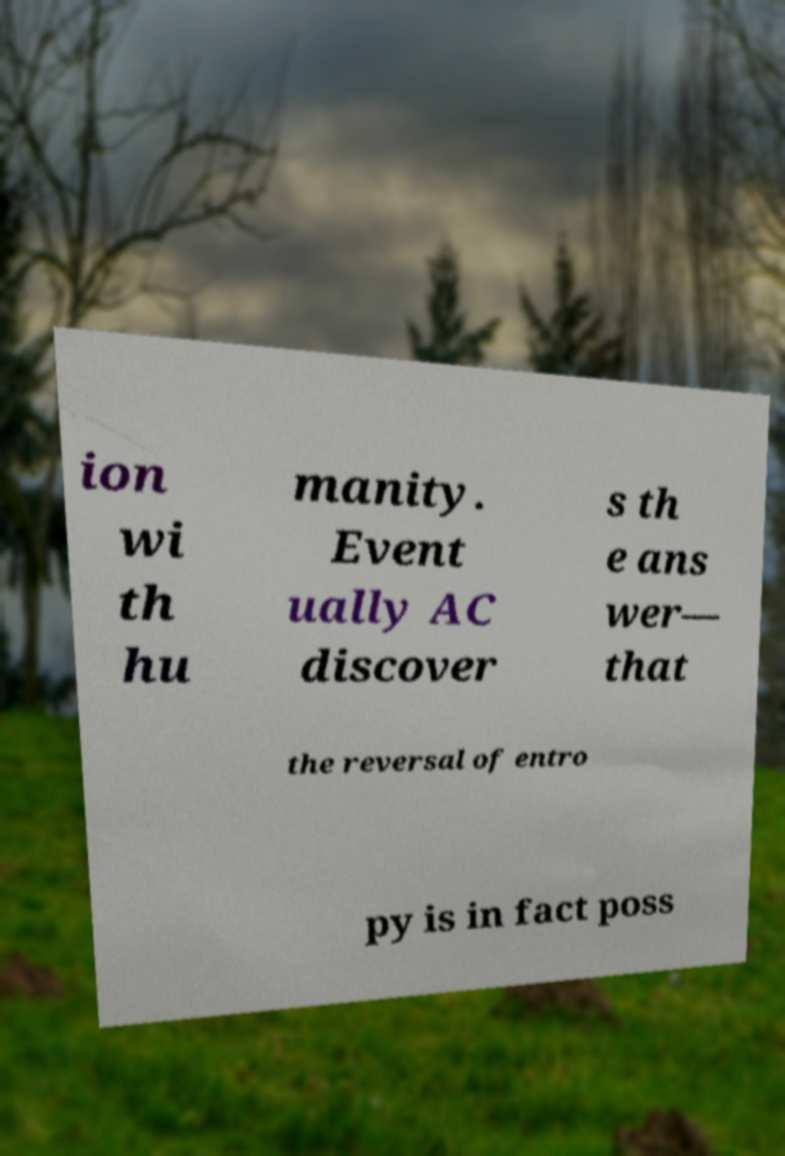Can you accurately transcribe the text from the provided image for me? ion wi th hu manity. Event ually AC discover s th e ans wer— that the reversal of entro py is in fact poss 